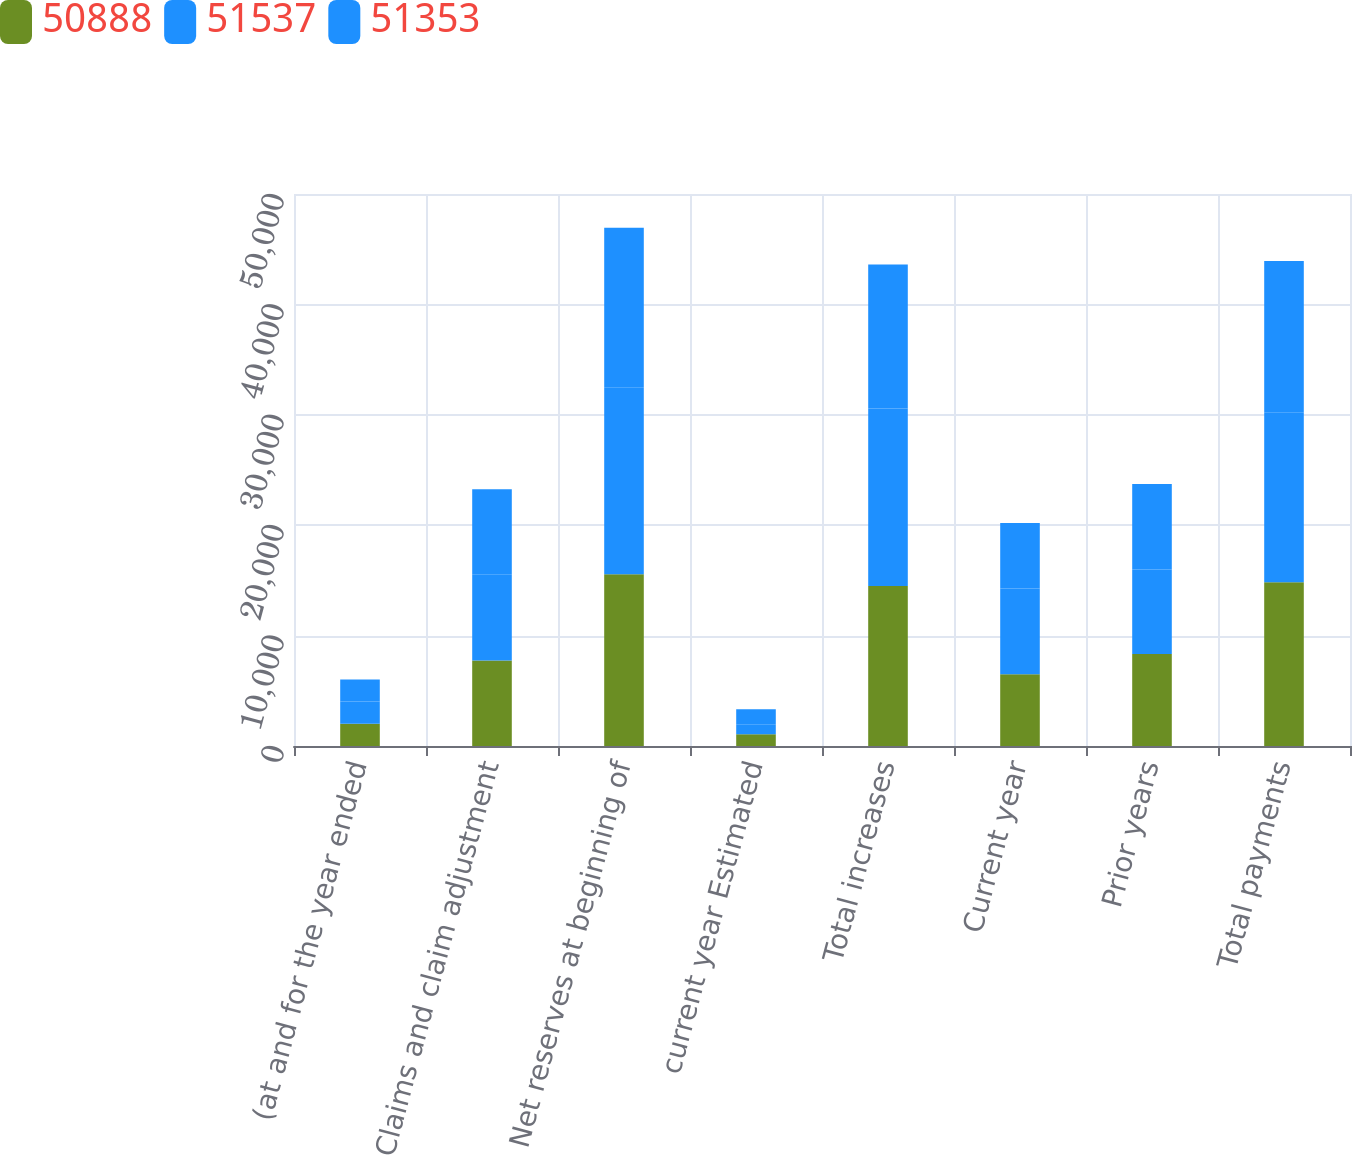<chart> <loc_0><loc_0><loc_500><loc_500><stacked_bar_chart><ecel><fcel>(at and for the year ended<fcel>Claims and claim adjustment<fcel>Net reserves at beginning of<fcel>current year Estimated<fcel>Total increases<fcel>Current year<fcel>Prior years<fcel>Total payments<nl><fcel>50888<fcel>2012<fcel>7751<fcel>15559<fcel>1074<fcel>14485<fcel>6507<fcel>8326<fcel>14833<nl><fcel>51537<fcel>2011<fcel>7751<fcel>16937<fcel>842<fcel>16095<fcel>7751<fcel>7653<fcel>15404<nl><fcel>51353<fcel>2010<fcel>7751<fcel>14452<fcel>1417<fcel>13035<fcel>5949<fcel>7748<fcel>13697<nl></chart> 